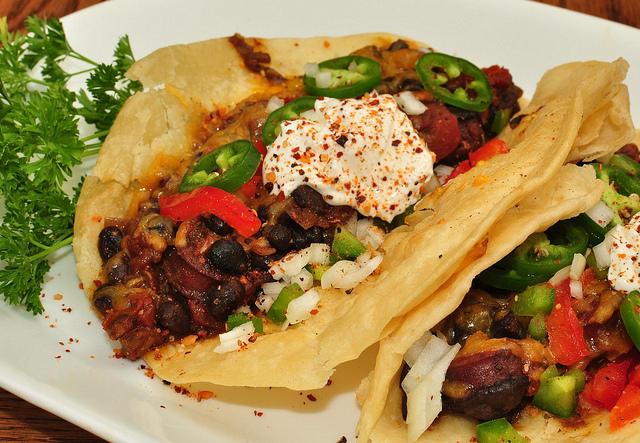What are the purple things on top of the hot do on the left?
Answer briefly. Beans. What is this meal?
Concise answer only. Tacos. How many Jalapenos are on the taco on the left?
Concise answer only. 4. What is red in the photo?
Quick response, please. Peppers. What is the green stuff on the side of plate?
Short answer required. Parsley. What is on the left side of the plate?
Concise answer only. Parsley. What is the red item on the plate?
Keep it brief. Tomato. What is the garnish?
Write a very short answer. Parsley. 